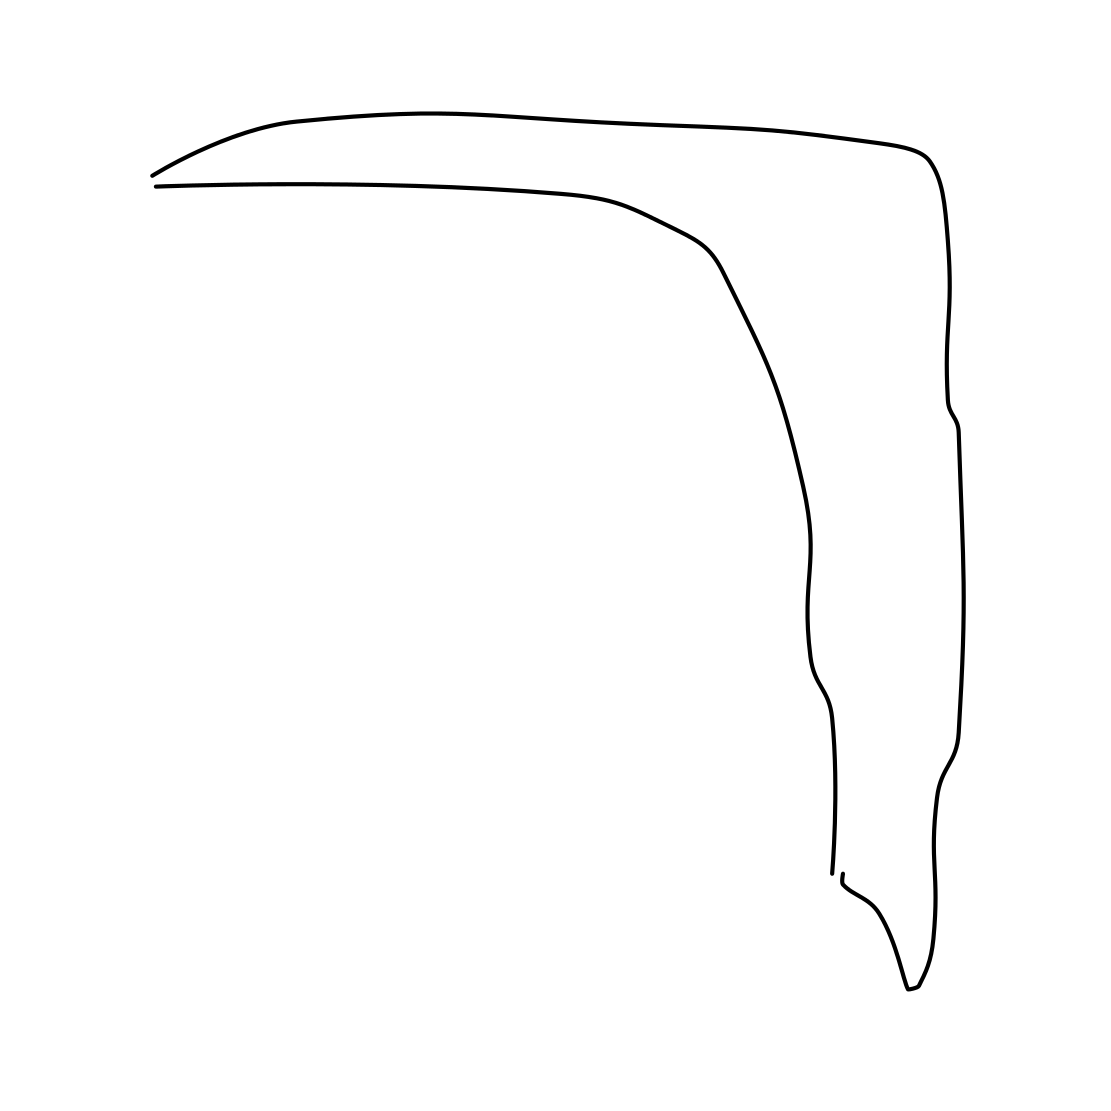What style or technique could this drawing be classified under? This drawing can be classified under line art, characterized by its simplicity and focus on contour without the use of shading or color variation. 